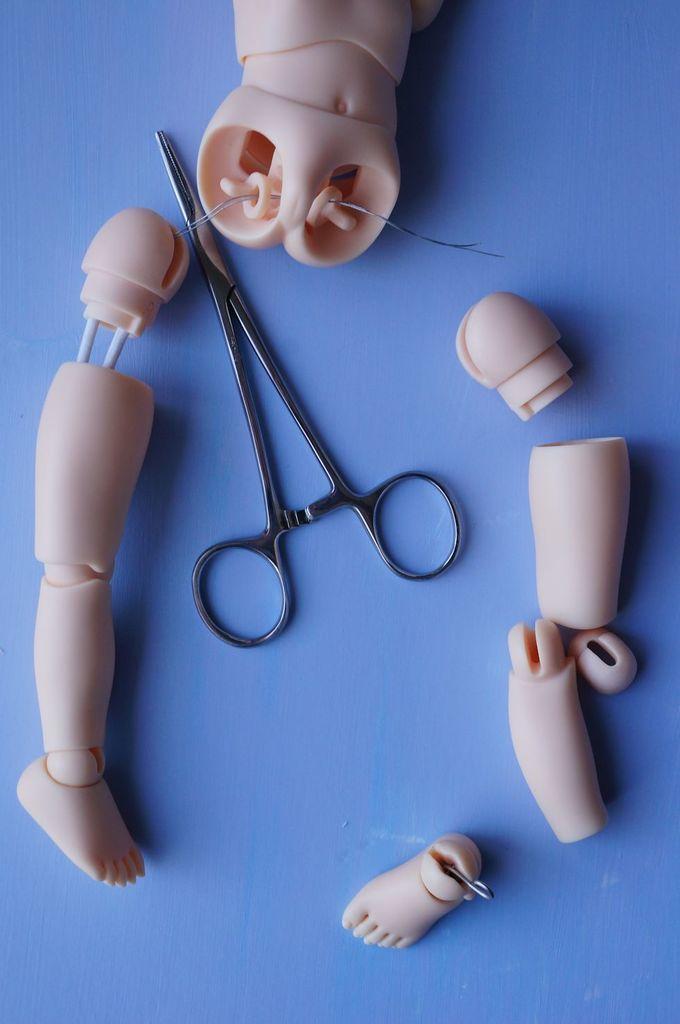Describe this image in one or two sentences. In this image there is a table on that table there is a scissor and different parts of a toy. 